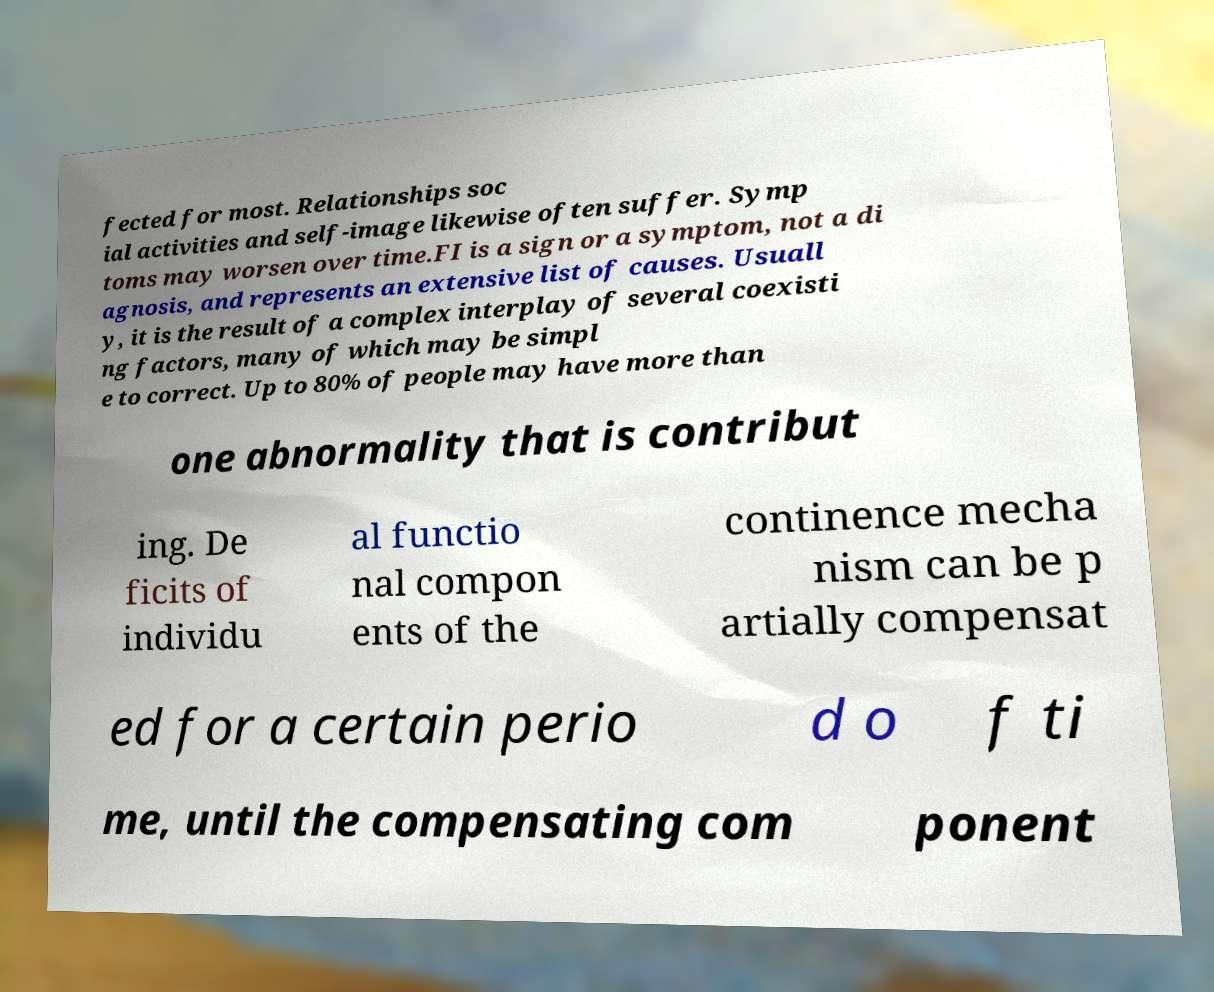For documentation purposes, I need the text within this image transcribed. Could you provide that? fected for most. Relationships soc ial activities and self-image likewise often suffer. Symp toms may worsen over time.FI is a sign or a symptom, not a di agnosis, and represents an extensive list of causes. Usuall y, it is the result of a complex interplay of several coexisti ng factors, many of which may be simpl e to correct. Up to 80% of people may have more than one abnormality that is contribut ing. De ficits of individu al functio nal compon ents of the continence mecha nism can be p artially compensat ed for a certain perio d o f ti me, until the compensating com ponent 